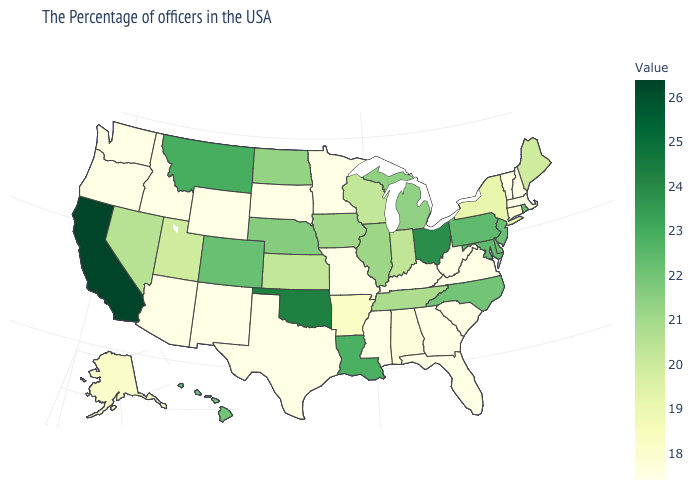Is the legend a continuous bar?
Quick response, please. Yes. Among the states that border Utah , which have the highest value?
Answer briefly. Colorado. Does Iowa have a higher value than Maryland?
Answer briefly. No. Does Delaware have the lowest value in the South?
Quick response, please. No. Is the legend a continuous bar?
Answer briefly. Yes. Among the states that border Virginia , does Maryland have the highest value?
Short answer required. Yes. Does Ohio have a higher value than Arkansas?
Answer briefly. Yes. Does the map have missing data?
Short answer required. No. 